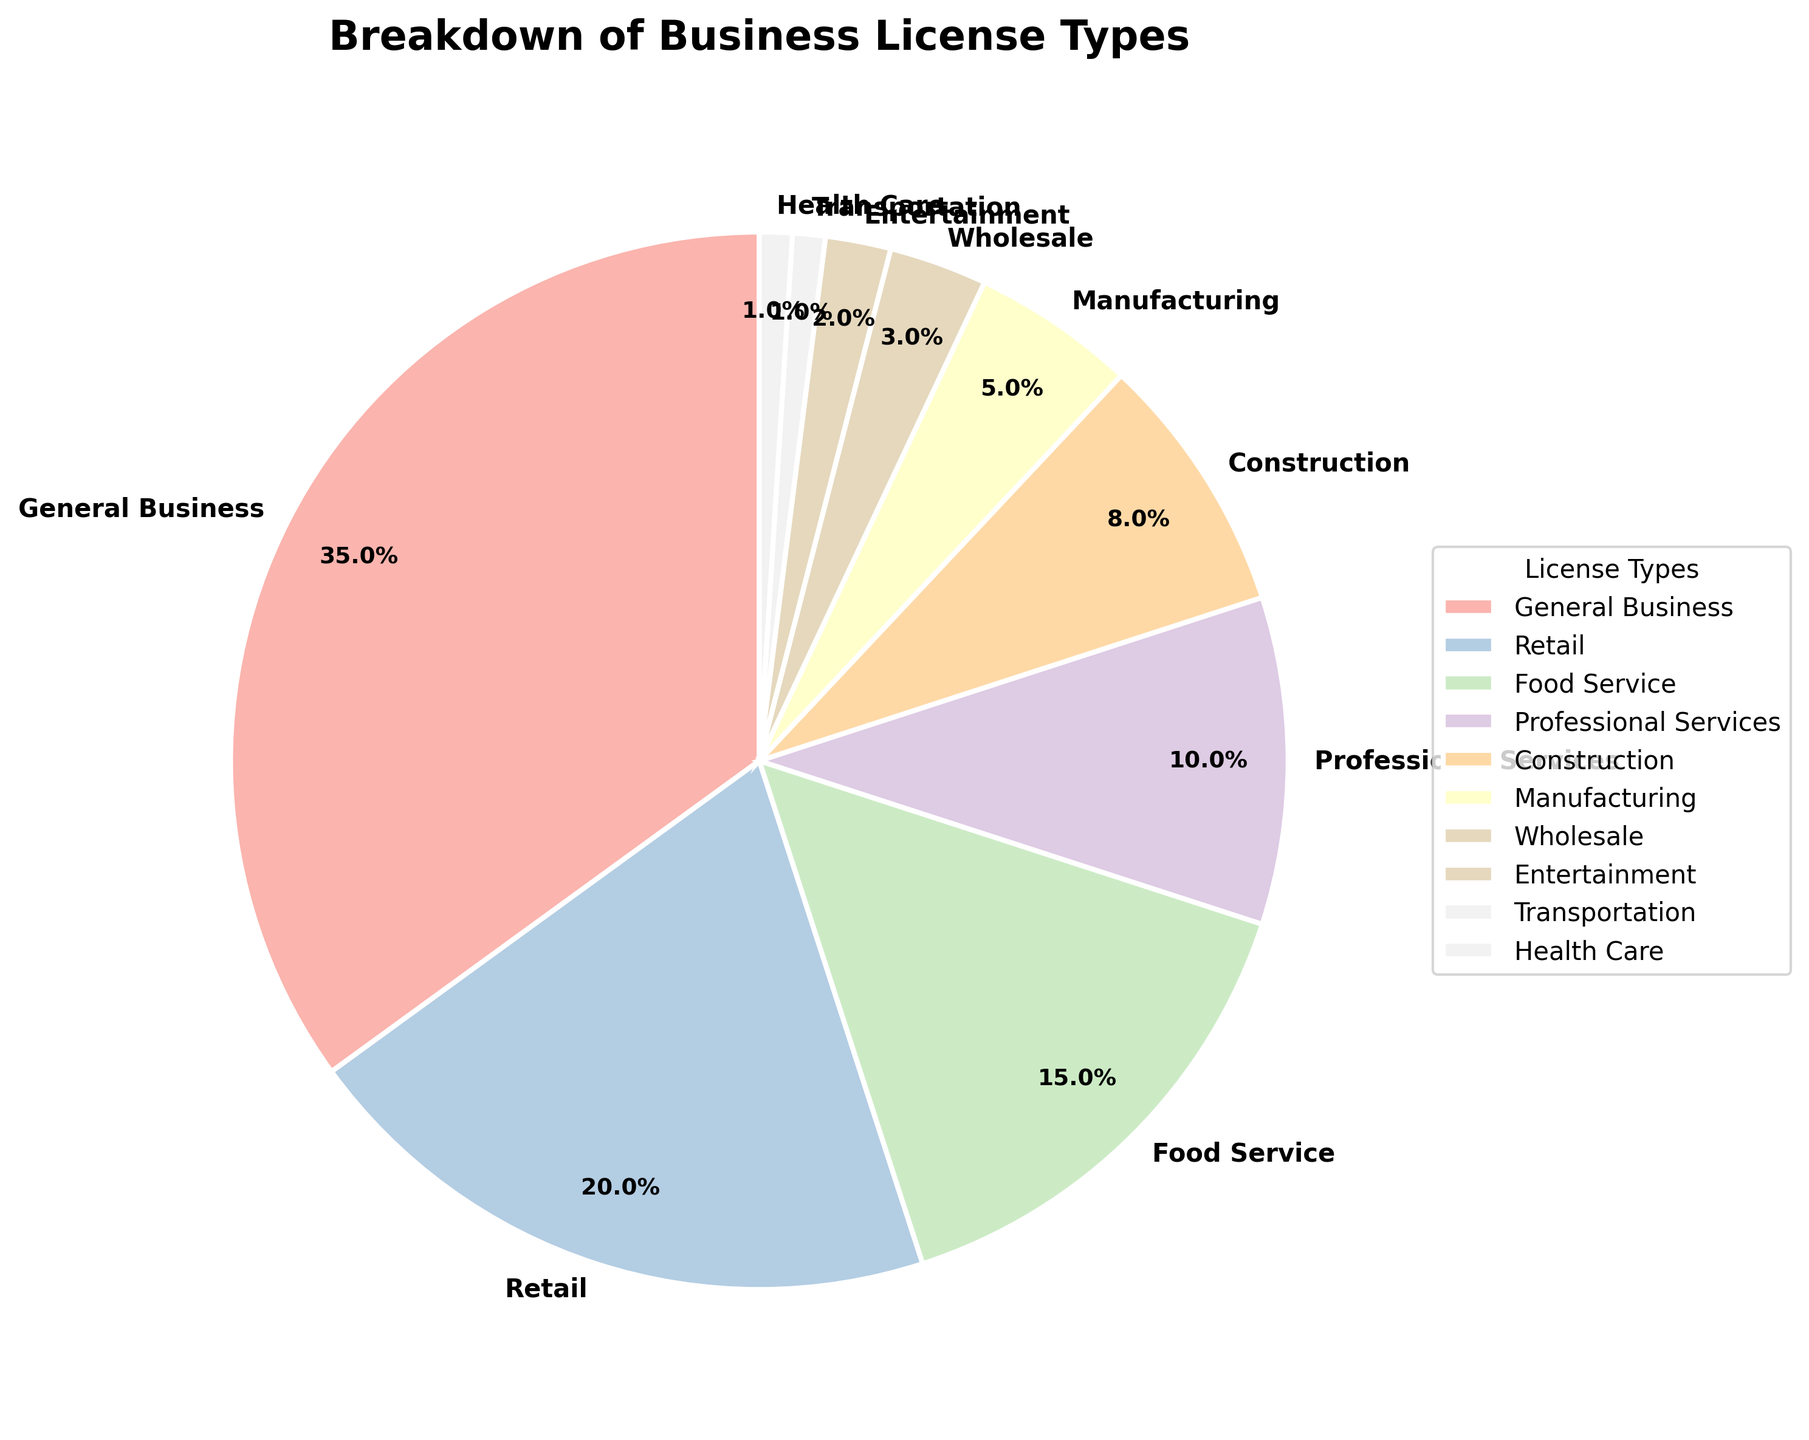Which license type has the highest percentage? The slice with the highest percentage is "General Business" at 35%.
Answer: General Business What is the combined percentage of Retail and Food Service licenses? Retail has 20% and Food Service has 15%, combining them gives 20% + 15% = 35%.
Answer: 35% How much more percentage do Retail licenses have compared to Construction licenses? Retail licenses have 20% and Construction licenses have 8%. The difference is 20% - 8% = 12%.
Answer: 12% Which three license types have the smallest percentages? The three smallest slices are Transportation (1%), Health Care (1%), and Entertainment (2%).
Answer: Transportation, Health Care, Entertainment Is the percentage of Professional Services licenses greater than or less than the percentage of Manufacturing licenses? Professional Services has 10% while Manufacturing has 5%, so Professional Services has a greater percentage.
Answer: Greater What is the exact percentage of the Wholesale license type? The Wholesale slice is labeled with 3%.
Answer: 3% What is the difference in percentage between the highest and the lowest license types? The highest, General Business, is 35%, and the lowest, both Transportation and Health Care, are 1%. The difference is 35% - 1% = 34%.
Answer: 34% What percentage of the licenses are for Entertainment and Transportation combined? Entertainment is 2% and Transportation is 1%. Summing them gives 2% + 1% = 3%.
Answer: 3% How many license types have a percentage greater than 10%? The license types with percentages greater than 10% are General Business (35%), Retail (20%), and Food Service (15%). Thus, there are 3 types.
Answer: 3 What is the average percentage of the Construction, Manufacturing, and Wholesale licenses? Summing Construction (8%), Manufacturing (5%), and Wholesale (3%) gives 8% + 5% + 3% = 16%. Dividing by 3 gives 16% / 3 = 5.33%.
Answer: 5.33% 